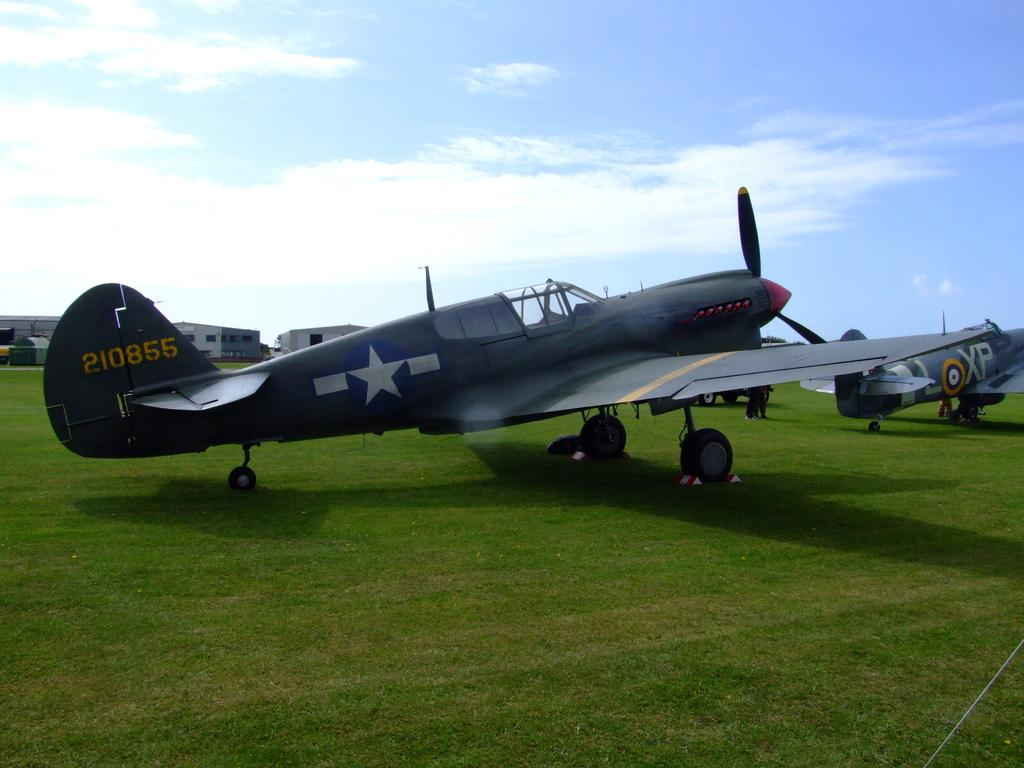<image>
Offer a succinct explanation of the picture presented. Aircraft 210855 sits on a field among other similar planes 